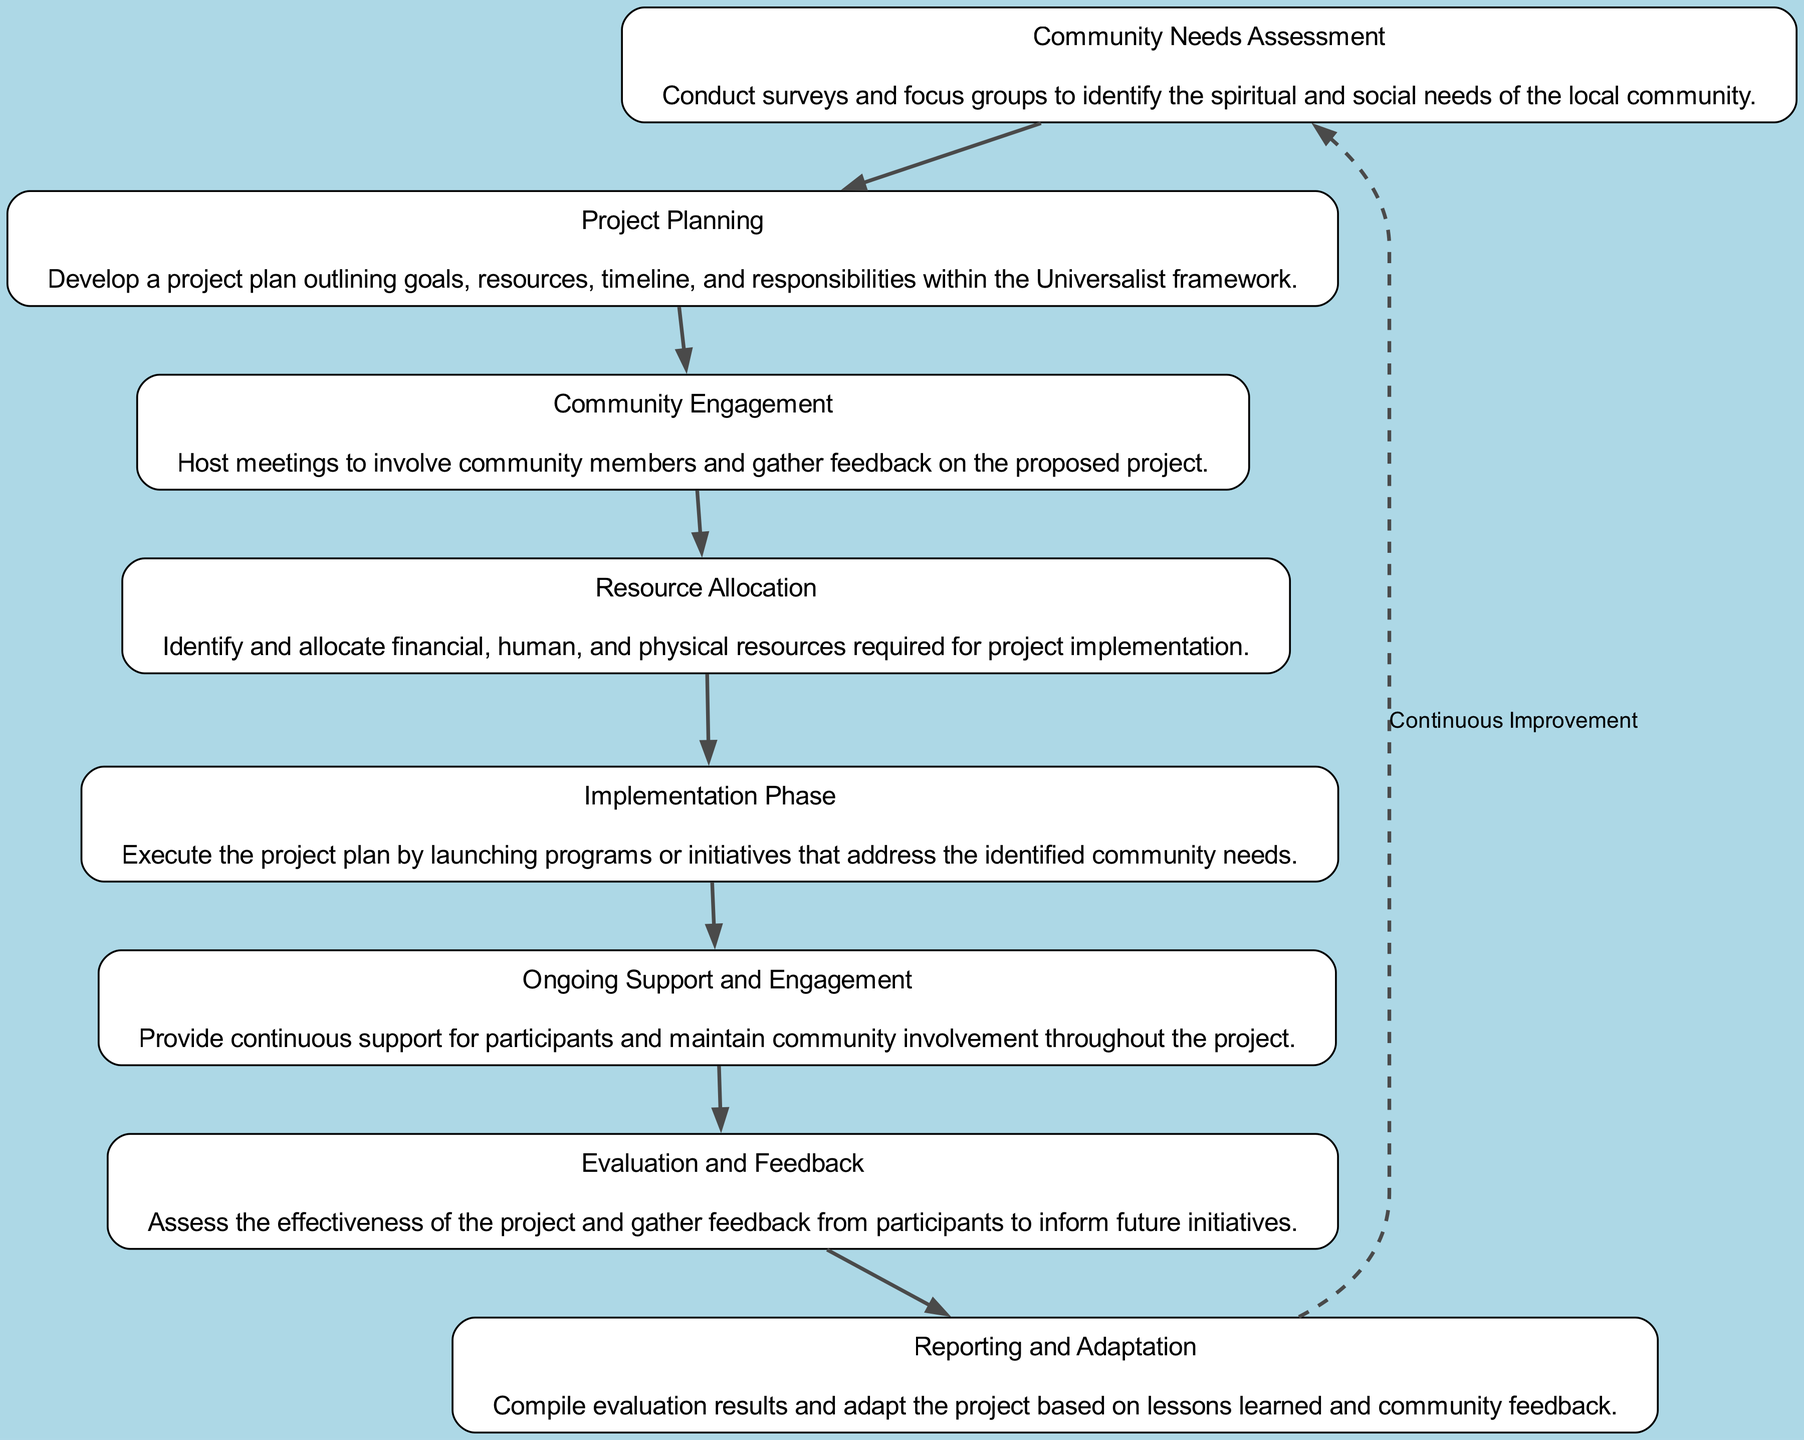What is the first step in the Universalist church project life cycle? The first step, as indicated in the diagram, is "Community Needs Assessment." This is the topmost node and initiates the project process.
Answer: Community Needs Assessment How many nodes are present in the flow chart? By counting each unique step represented in the diagram, we find there are eight nodes in total.
Answer: 8 What node follows 'Community Engagement'? The flow of the diagram shows that after 'Community Engagement', the next step is 'Resource Allocation'.
Answer: Resource Allocation Which phase comes after 'Implementation Phase'? Following the 'Implementation Phase', the diagram indicates that 'Ongoing Support and Engagement' is the next phase in the project life cycle.
Answer: Ongoing Support and Engagement What is the purpose of the 'Reporting and Adaptation' phase? This phase is aimed at compiling evaluation results and adapting the project based on lessons learned and community feedback. It is crucial for continuous improvement, as indicated in the diagram.
Answer: Compile evaluation results and adapt the project How does 'Community Needs Assessment' connect to 'Evaluation and Feedback'? The diagram's flow connects 'Community Needs Assessment' directly to 'Project Planning', eventually leading through to 'Evaluation and Feedback', which assesses the outcomes of the earlier phases.
Answer: Through Project Planning and other intermediate steps What indicates the cyclical nature of the project life cycle in the diagram? The dashed edge from 'Evaluation and Feedback' back to 'Community Needs Assessment' signifies the continuous improvement aspect of the Universalist church project life cycle, indicating that the process can repeat indefinitely based on feedback.
Answer: A dashed edge labeled 'Continuous Improvement' What is the main goal specified in 'Project Planning'? The main goal in 'Project Planning' as presented in the diagram is to develop a project plan detailing goals, resources, timeline, and responsibilities within the Universalist framework.
Answer: Develop a project plan outlining goals, resources, timeline, and responsibilities 